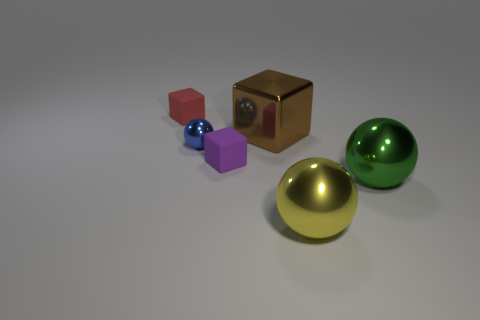Subtract all purple matte cubes. How many cubes are left? 2 Subtract all green balls. How many balls are left? 2 Subtract 1 spheres. How many spheres are left? 2 Subtract all purple cubes. How many green balls are left? 1 Subtract all red metallic balls. Subtract all large metal objects. How many objects are left? 3 Add 3 small red matte objects. How many small red matte objects are left? 4 Add 3 tiny brown metal cubes. How many tiny brown metal cubes exist? 3 Add 2 big blue shiny spheres. How many objects exist? 8 Subtract 1 yellow spheres. How many objects are left? 5 Subtract all green cubes. Subtract all green spheres. How many cubes are left? 3 